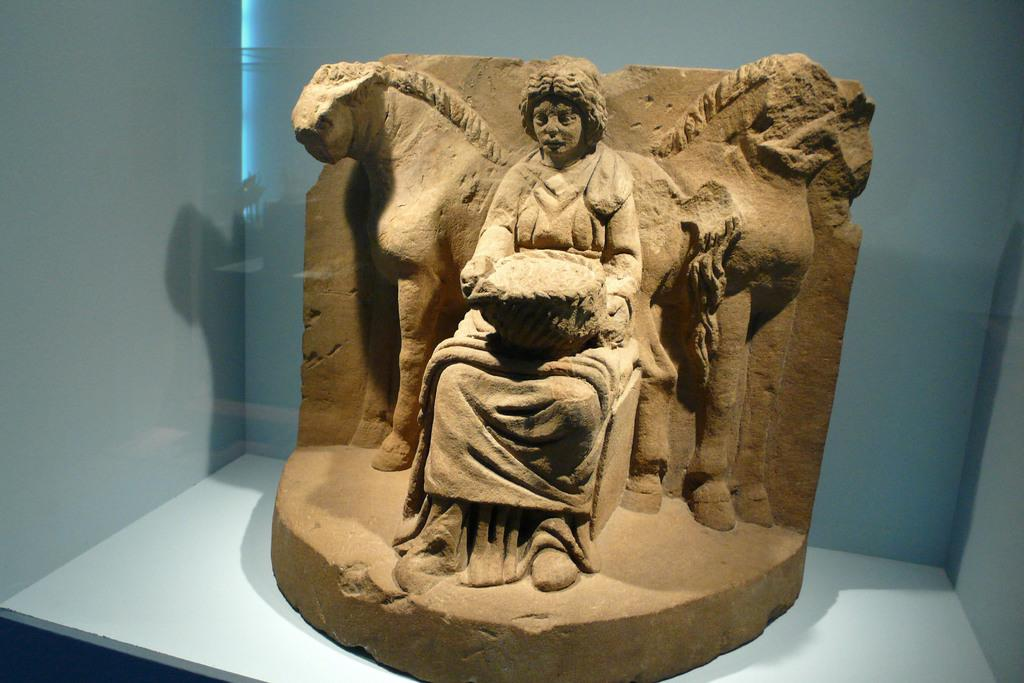What is the main subject of the image? There is a sculpture in the image. Where is the sculpture located? The sculpture is in a shelf. What type of trousers is the sculpture wearing in the image? The sculpture is not a person and therefore does not wear trousers. The sculpture is an inanimate object, and the question is not applicable to the image. 